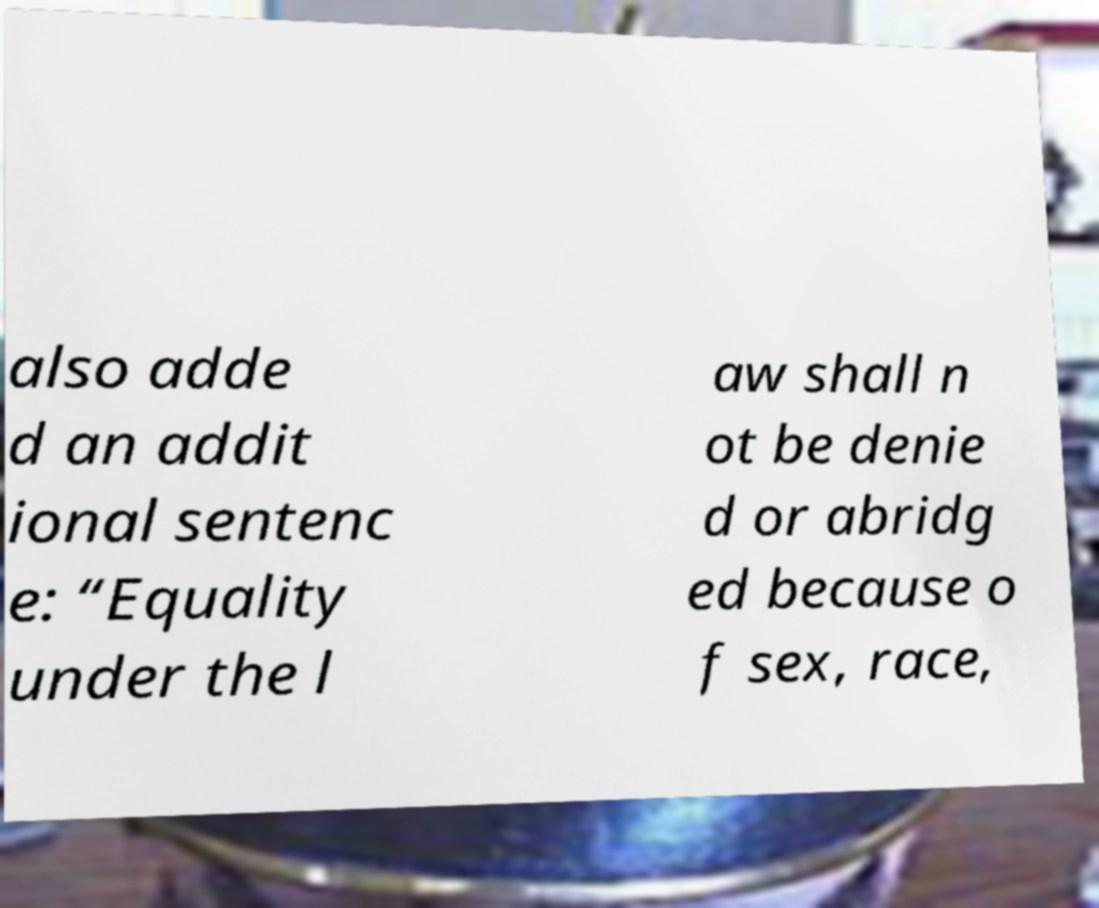Could you assist in decoding the text presented in this image and type it out clearly? also adde d an addit ional sentenc e: “Equality under the l aw shall n ot be denie d or abridg ed because o f sex, race, 